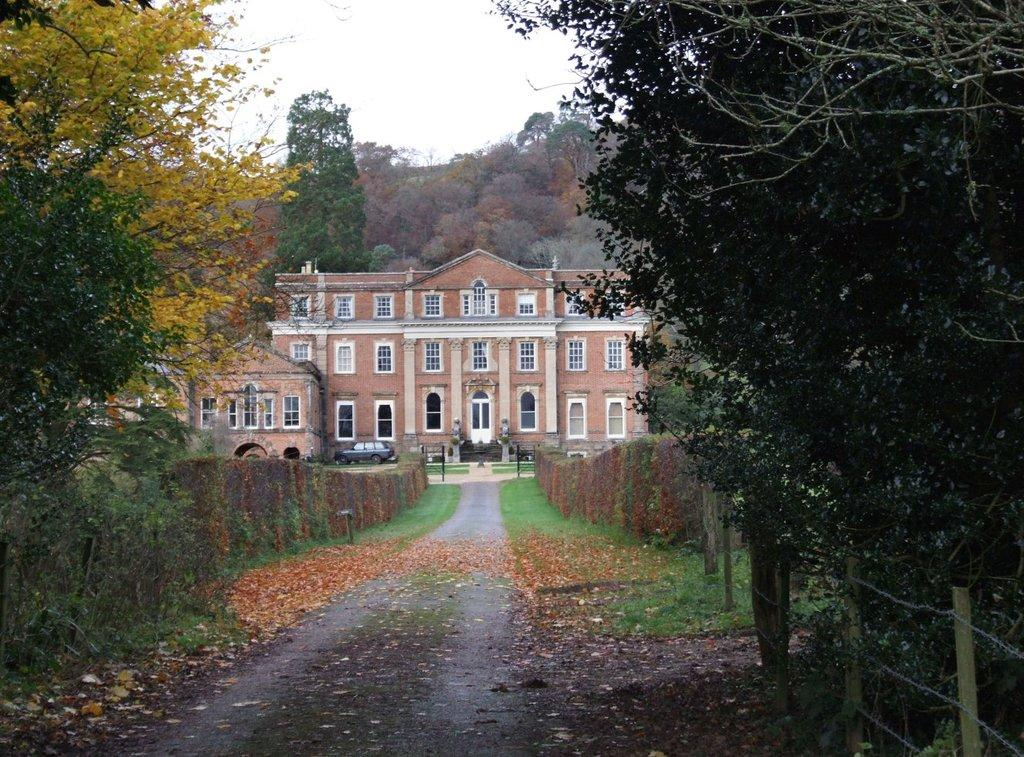What type of vegetation can be seen on the ground in the image? There are dry leaves and grass on the ground in the image. What type of plants are present in the image? There are bushes in the image. What type of barrier is visible in the image? There is fencing in the image. What type of man-made structure is present in the image? There is a building in the image. What type of vehicle is present in the image? There is a vehicle in the image. What other objects can be seen in the image? There are other objects in the image, but their specific details are not mentioned in the provided facts. What part of the natural environment is visible in the image? The sky is visible in the image. How many servants are attending to the building in the image? There is no mention of servants in the image or the provided facts. What type of cable is connected to the vehicle in the image? There is no mention of a cable connected to the vehicle in the image or the provided facts. 